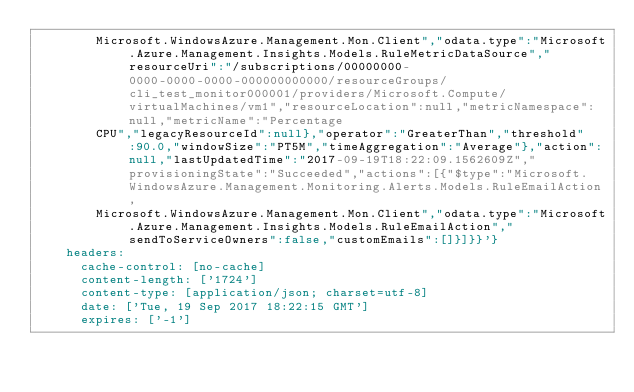<code> <loc_0><loc_0><loc_500><loc_500><_YAML_>        Microsoft.WindowsAzure.Management.Mon.Client","odata.type":"Microsoft.Azure.Management.Insights.Models.RuleMetricDataSource","resourceUri":"/subscriptions/00000000-0000-0000-0000-000000000000/resourceGroups/cli_test_monitor000001/providers/Microsoft.Compute/virtualMachines/vm1","resourceLocation":null,"metricNamespace":null,"metricName":"Percentage
        CPU","legacyResourceId":null},"operator":"GreaterThan","threshold":90.0,"windowSize":"PT5M","timeAggregation":"Average"},"action":null,"lastUpdatedTime":"2017-09-19T18:22:09.1562609Z","provisioningState":"Succeeded","actions":[{"$type":"Microsoft.WindowsAzure.Management.Monitoring.Alerts.Models.RuleEmailAction,
        Microsoft.WindowsAzure.Management.Mon.Client","odata.type":"Microsoft.Azure.Management.Insights.Models.RuleEmailAction","sendToServiceOwners":false,"customEmails":[]}]}}'}
    headers:
      cache-control: [no-cache]
      content-length: ['1724']
      content-type: [application/json; charset=utf-8]
      date: ['Tue, 19 Sep 2017 18:22:15 GMT']
      expires: ['-1']</code> 